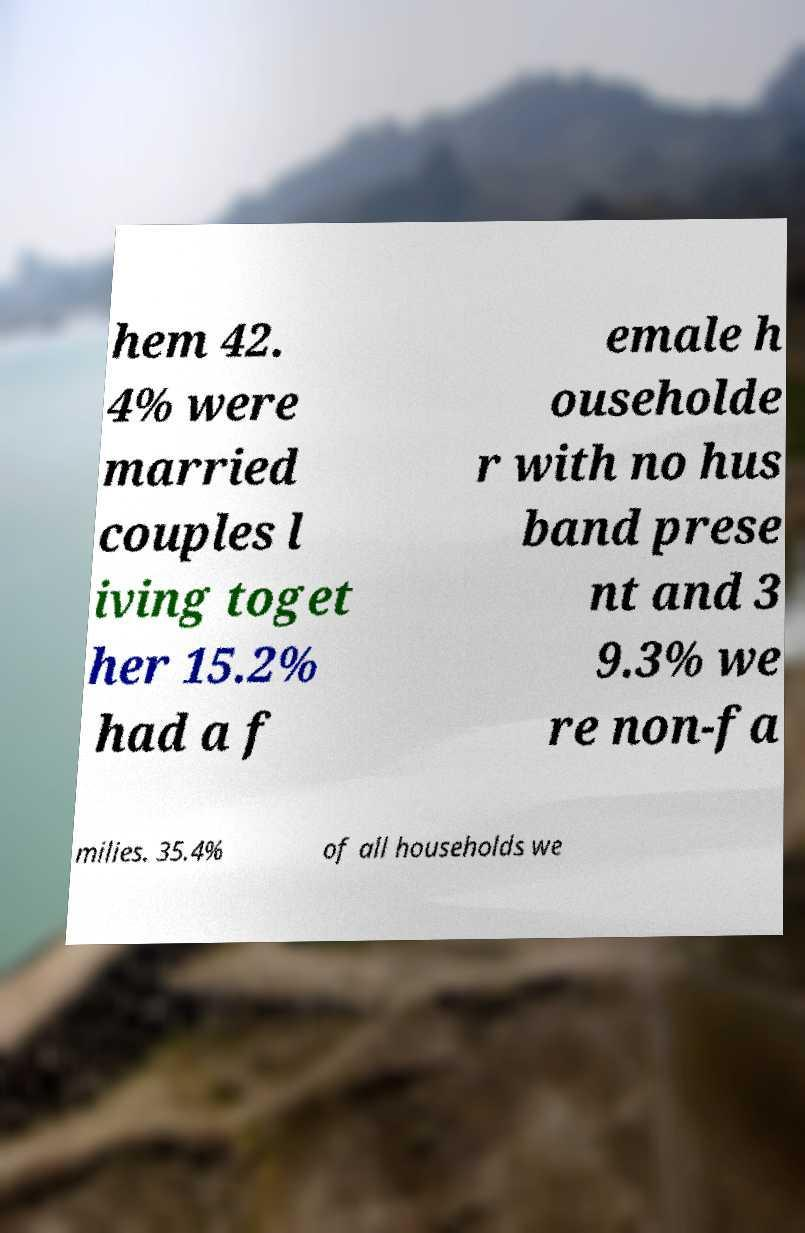Could you extract and type out the text from this image? hem 42. 4% were married couples l iving toget her 15.2% had a f emale h ouseholde r with no hus band prese nt and 3 9.3% we re non-fa milies. 35.4% of all households we 